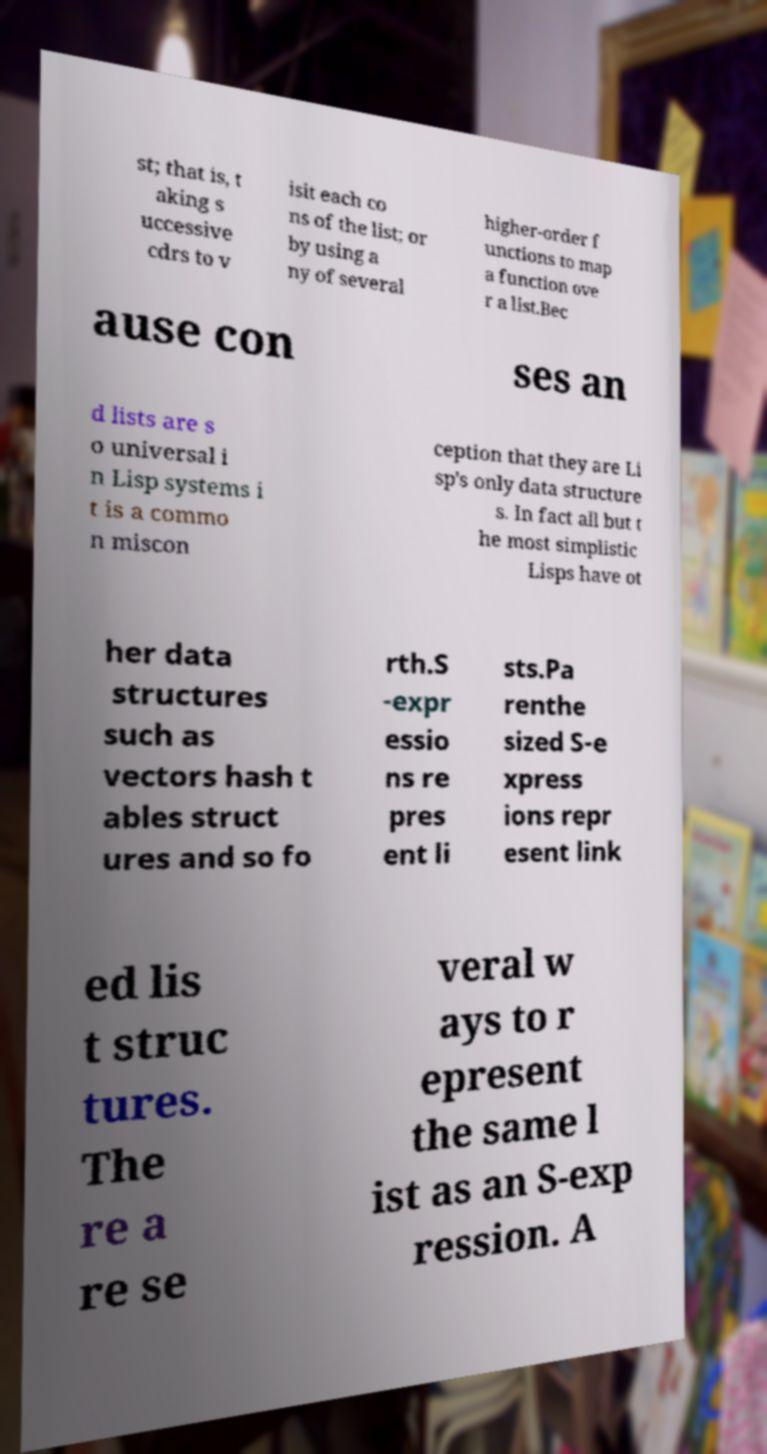I need the written content from this picture converted into text. Can you do that? st; that is, t aking s uccessive cdrs to v isit each co ns of the list; or by using a ny of several higher-order f unctions to map a function ove r a list.Bec ause con ses an d lists are s o universal i n Lisp systems i t is a commo n miscon ception that they are Li sp's only data structure s. In fact all but t he most simplistic Lisps have ot her data structures such as vectors hash t ables struct ures and so fo rth.S -expr essio ns re pres ent li sts.Pa renthe sized S-e xpress ions repr esent link ed lis t struc tures. The re a re se veral w ays to r epresent the same l ist as an S-exp ression. A 